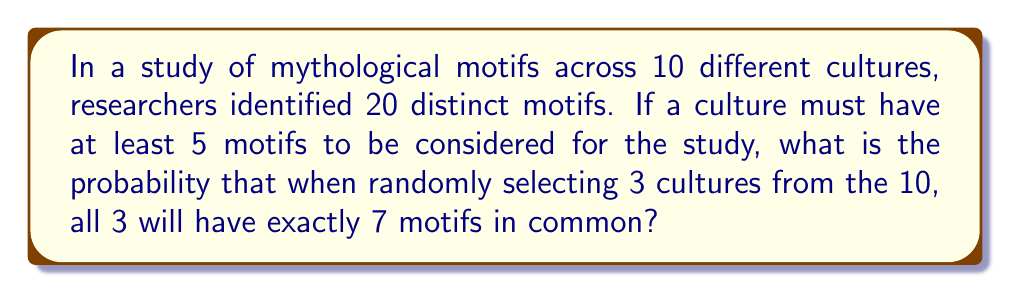Give your solution to this math problem. Let's approach this step-by-step:

1) First, we need to calculate the number of ways to choose 7 motifs from 20:
   $$\binom{20}{7} = \frac{20!}{7!(20-7)!} = \frac{20!}{7!13!} = 77,520$$

2) Now, for each culture, we need to choose exactly 7 motifs. The probability of this for one culture is:
   $$P(\text{7 motifs}) = \frac{\binom{20}{7}}{\sum_{i=5}^{20}\binom{20}{i}}$$

3) Let's calculate the denominator:
   $$\sum_{i=5}^{20}\binom{20}{i} = 1,048,575$$

4) So, the probability for one culture is:
   $$P(\text{7 motifs}) = \frac{77,520}{1,048,575} \approx 0.07393$$

5) For all 3 selected cultures to have exactly 7 motifs, and for these 7 motifs to be the same, we multiply this probability by itself twice more:
   $$P(\text{3 cultures, 7 common motifs}) = (0.07393)^3 \approx 0.000404$$

6) Finally, we need to account for choosing 3 cultures out of 10:
   $$\binom{10}{3} = \frac{10!}{3!(10-3)!} = \frac{10!}{3!7!} = 120$$

7) The final probability is:
   $$120 \cdot (0.07393)^3 \approx 0.0485$$
Answer: $0.0485$ or $4.85\%$ 